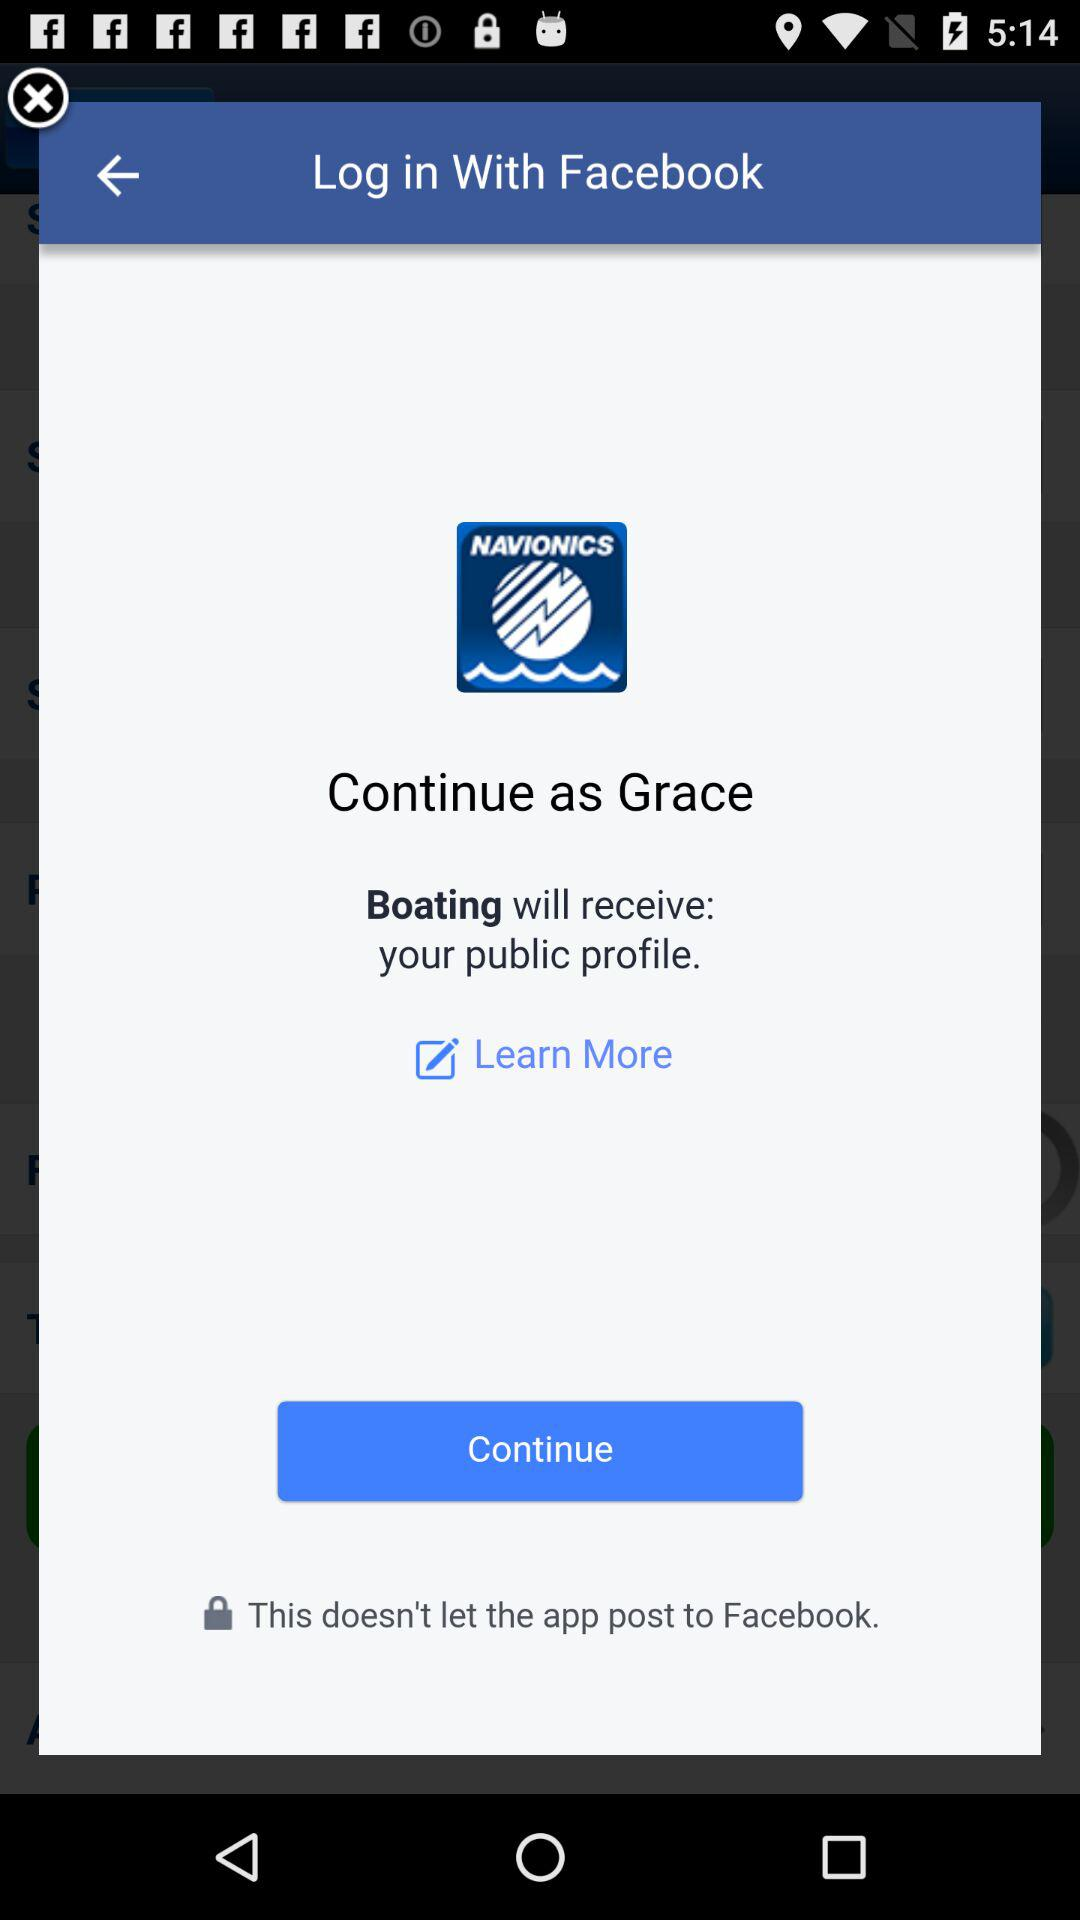When will "Boating" receive the public profile?
When the provided information is insufficient, respond with <no answer>. <no answer> 